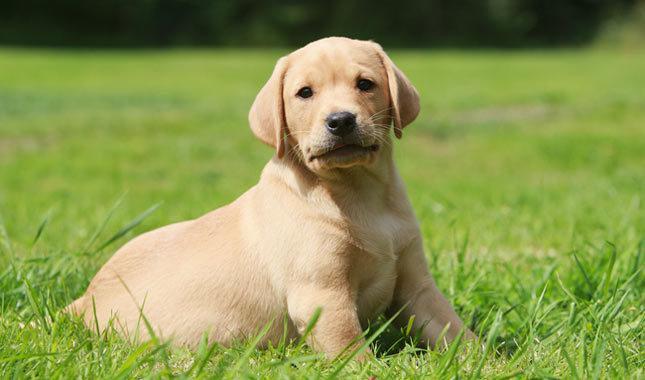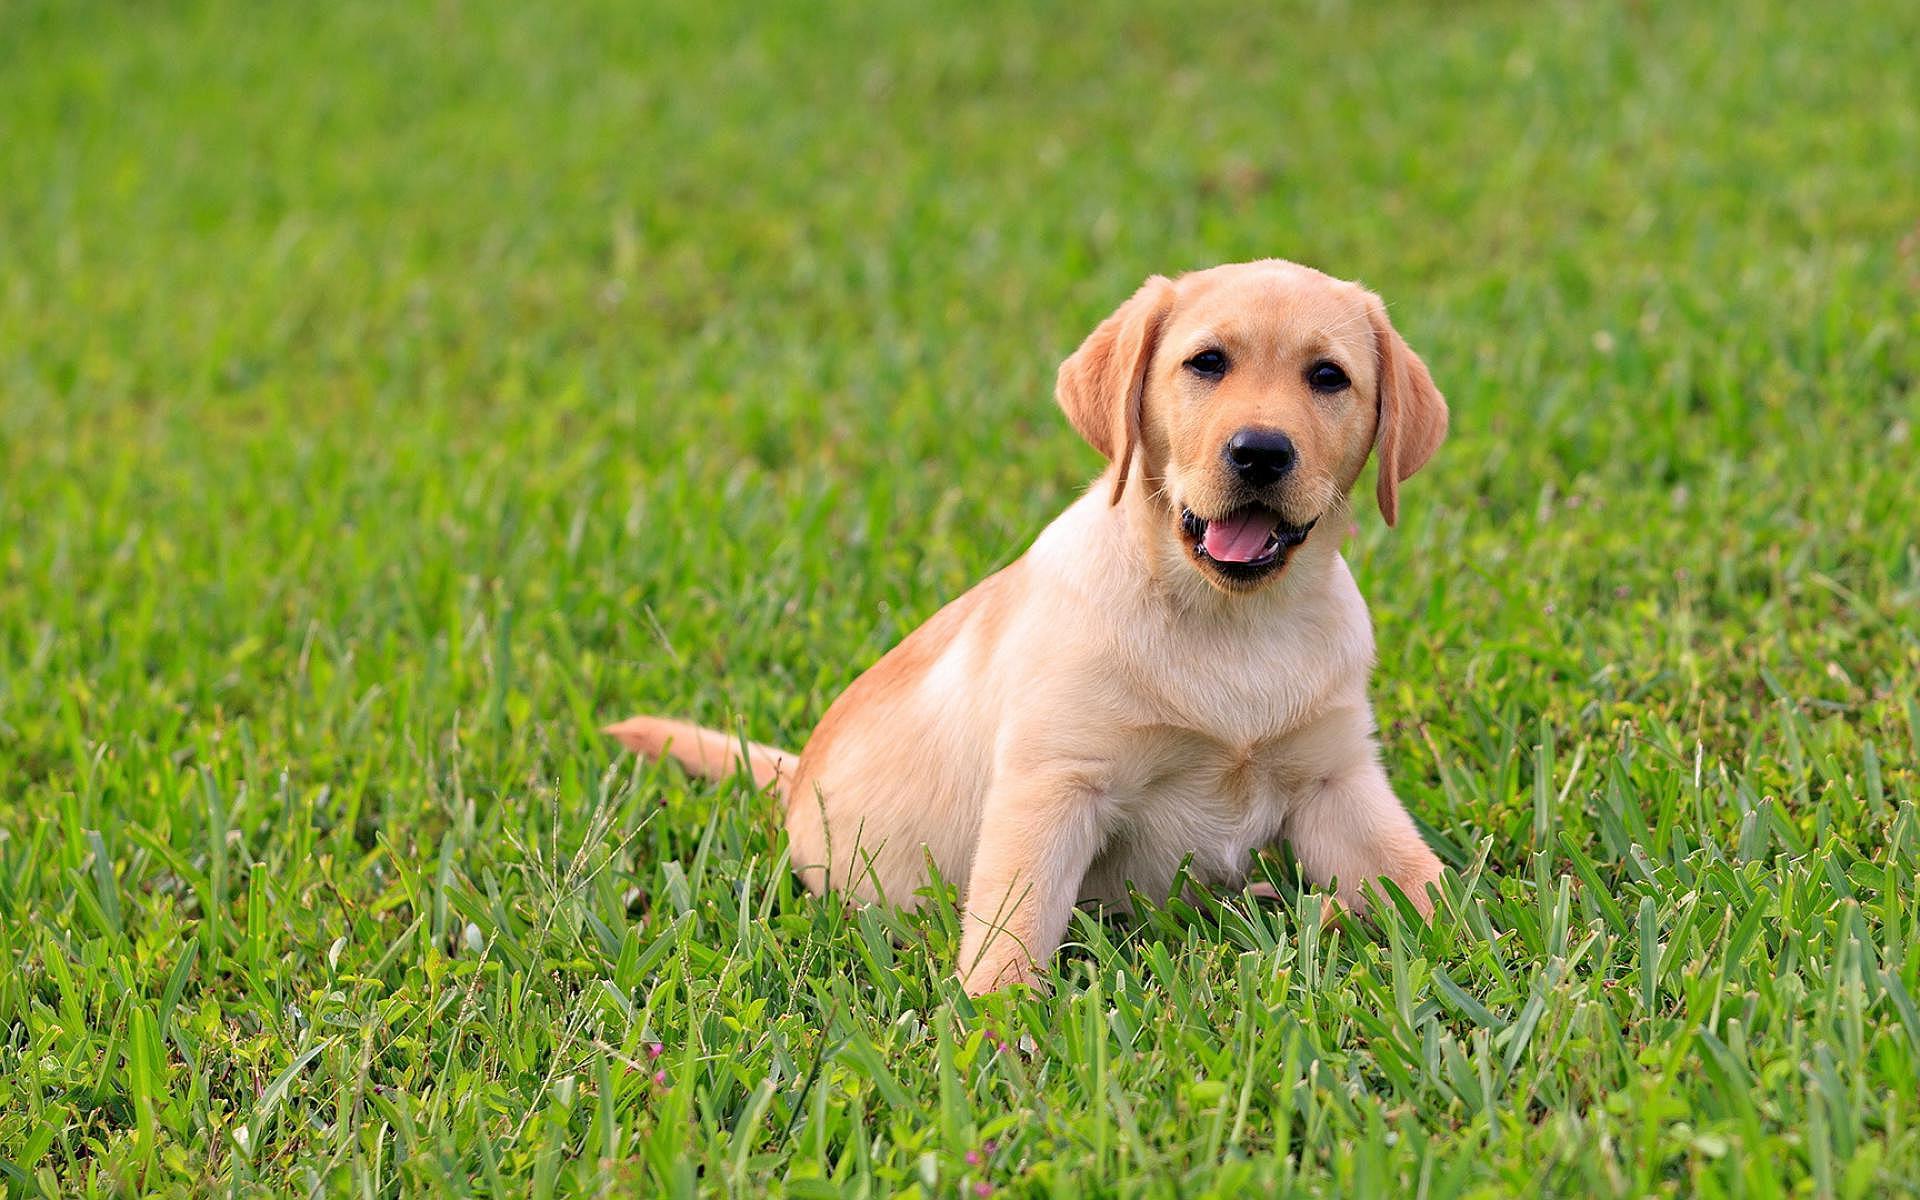The first image is the image on the left, the second image is the image on the right. Considering the images on both sides, is "the dog on the right image has its mouth open" valid? Answer yes or no. Yes. 